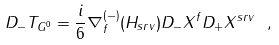Convert formula to latex. <formula><loc_0><loc_0><loc_500><loc_500>D _ { - } T _ { G ^ { 0 } } = \frac { i } { 6 } \nabla ^ { ( - ) } _ { f } ( H _ { s r v } ) D _ { - } X ^ { f } D _ { + } X ^ { s r v } \ ,</formula> 